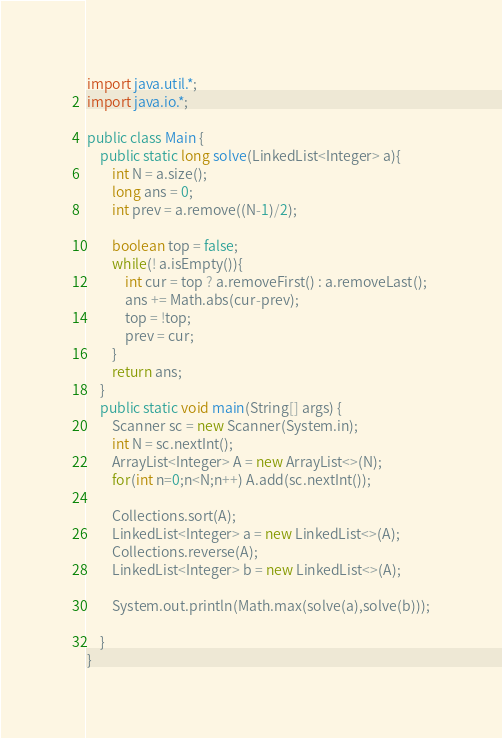<code> <loc_0><loc_0><loc_500><loc_500><_Java_>import java.util.*;
import java.io.*;

public class Main {
    public static long solve(LinkedList<Integer> a){
    	int N = a.size();
    	long ans = 0;
    	int prev = a.remove((N-1)/2);
    	
    	boolean top = false;
    	while(! a.isEmpty()){
    		int cur = top ? a.removeFirst() : a.removeLast();
    		ans += Math.abs(cur-prev);
    		top = !top;
    		prev = cur;
    	}
    	return ans;
    }
    public static void main(String[] args) {
        Scanner sc = new Scanner(System.in);
        int N = sc.nextInt();
        ArrayList<Integer> A = new ArrayList<>(N);
        for(int n=0;n<N;n++) A.add(sc.nextInt());
        
        Collections.sort(A);
        LinkedList<Integer> a = new LinkedList<>(A);
        Collections.reverse(A);
        LinkedList<Integer> b = new LinkedList<>(A);
        
        System.out.println(Math.max(solve(a),solve(b)));
        
    }
}</code> 